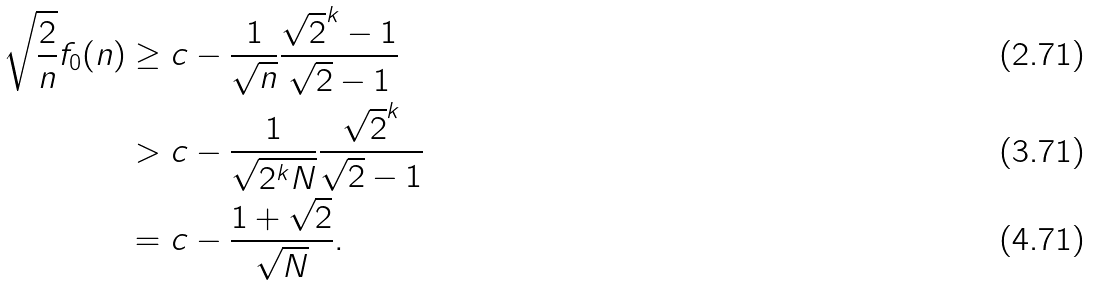Convert formula to latex. <formula><loc_0><loc_0><loc_500><loc_500>\sqrt { \frac { 2 } { n } } f _ { 0 } ( n ) & \geq c - \frac { 1 } { \sqrt { n } } \frac { \sqrt { 2 } ^ { k } - 1 } { \sqrt { 2 } - 1 } \\ & > c - \frac { 1 } { \sqrt { 2 ^ { k } N } } \frac { \sqrt { 2 } ^ { k } } { \sqrt { 2 } - 1 } \\ & = c - \frac { 1 + \sqrt { 2 } } { \sqrt { N } } .</formula> 